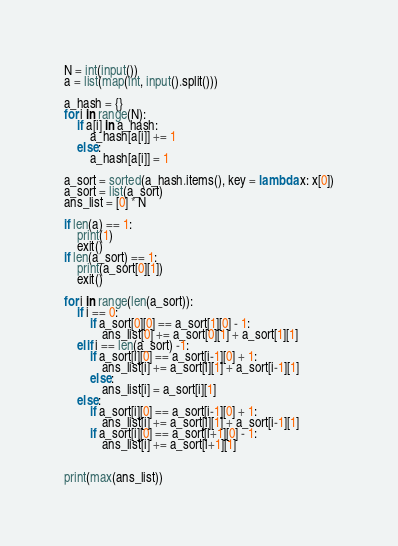Convert code to text. <code><loc_0><loc_0><loc_500><loc_500><_Python_>N = int(input())
a = list(map(int, input().split()))

a_hash = {}
for i in range(N):
    if a[i] in a_hash:
        a_hash[a[i]] += 1
    else:
        a_hash[a[i]] = 1

a_sort = sorted(a_hash.items(), key = lambda x: x[0])
a_sort = list(a_sort)
ans_list = [0] * N

if len(a) == 1:
    print(1)
    exit()
if len(a_sort) == 1:
    print(a_sort[0][1])
    exit()

for i in range(len(a_sort)):
    if i == 0:
        if a_sort[0][0] == a_sort[1][0] - 1:
            ans_list[0] += a_sort[0][1] + a_sort[1][1]
    elif i == len(a_sort) -1:
        if a_sort[i][0] == a_sort[i-1][0] + 1:
            ans_list[i] += a_sort[i][1] + a_sort[i-1][1]
        else:
            ans_list[i] = a_sort[i][1]
    else:
        if a_sort[i][0] == a_sort[i-1][0] + 1:
            ans_list[i] += a_sort[i][1] + a_sort[i-1][1]
        if a_sort[i][0] == a_sort[i+1][0] - 1:
            ans_list[i] += a_sort[i+1][1]


print(max(ans_list))</code> 